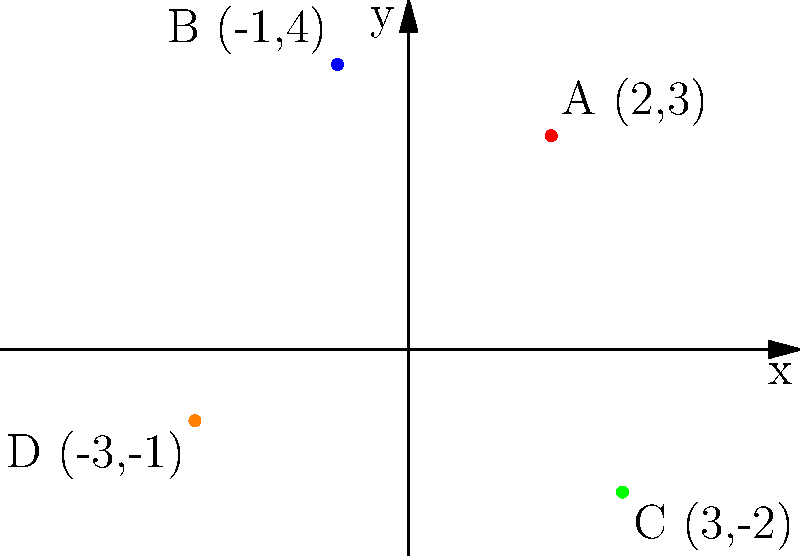Given the strategic military positions plotted on the coordinate plane above, calculate the distance between position A and position C using the distance formula. To solve this problem, we'll use the distance formula between two points:

$$ d = \sqrt{(x_2 - x_1)^2 + (y_2 - y_1)^2} $$

Where $(x_1, y_1)$ are the coordinates of the first point and $(x_2, y_2)$ are the coordinates of the second point.

Step 1: Identify the coordinates of positions A and C.
Position A: (2, 3)
Position C: (3, -2)

Step 2: Plug the coordinates into the distance formula.
$$ d = \sqrt{(3 - 2)^2 + (-2 - 3)^2} $$

Step 3: Simplify the expressions inside the parentheses.
$$ d = \sqrt{(1)^2 + (-5)^2} $$

Step 4: Calculate the squares.
$$ d = \sqrt{1 + 25} $$

Step 5: Add the numbers under the square root.
$$ d = \sqrt{26} $$

Step 6: Simplify the square root if possible. In this case, 26 is not a perfect square, so we leave it as is.

Therefore, the distance between position A and position C is $\sqrt{26}$ units.
Answer: $\sqrt{26}$ units 